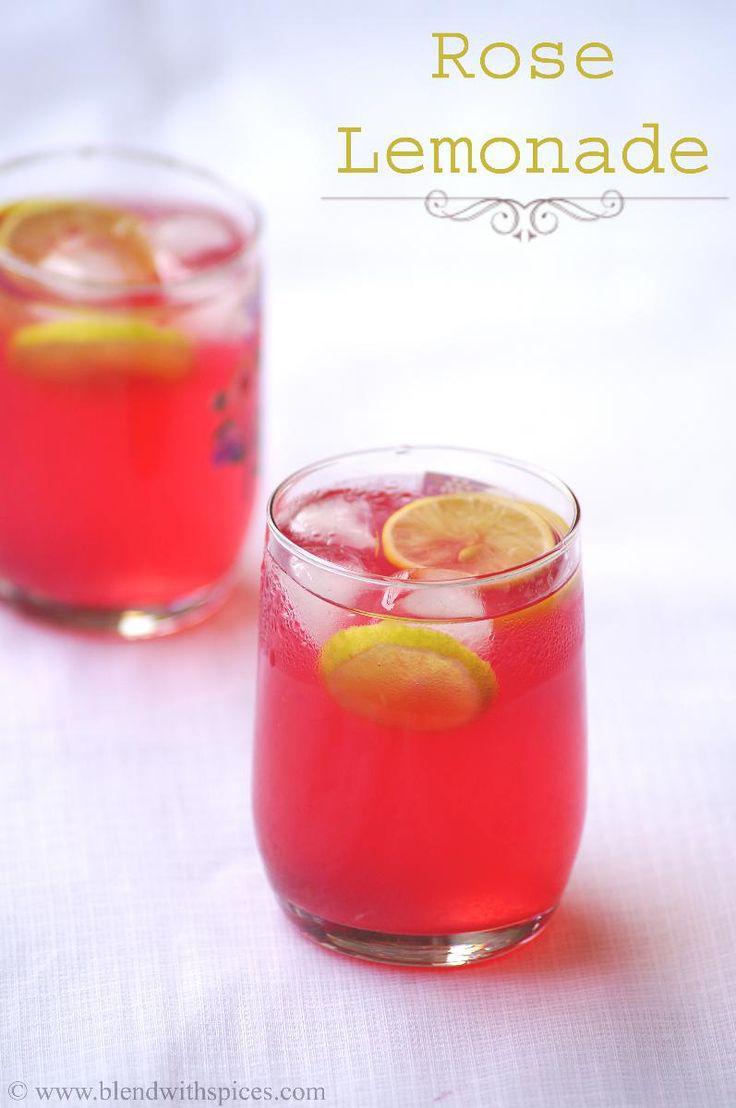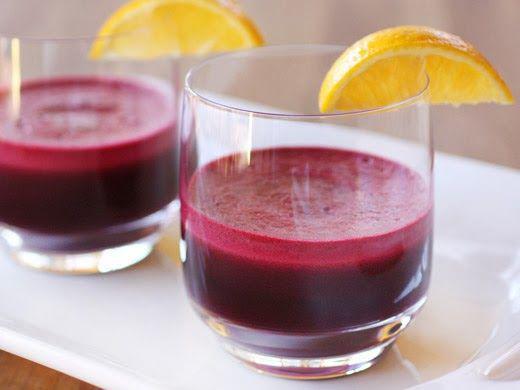The first image is the image on the left, the second image is the image on the right. Analyze the images presented: Is the assertion "All of the images contain only one glass that is filled with a beverage." valid? Answer yes or no. No. 